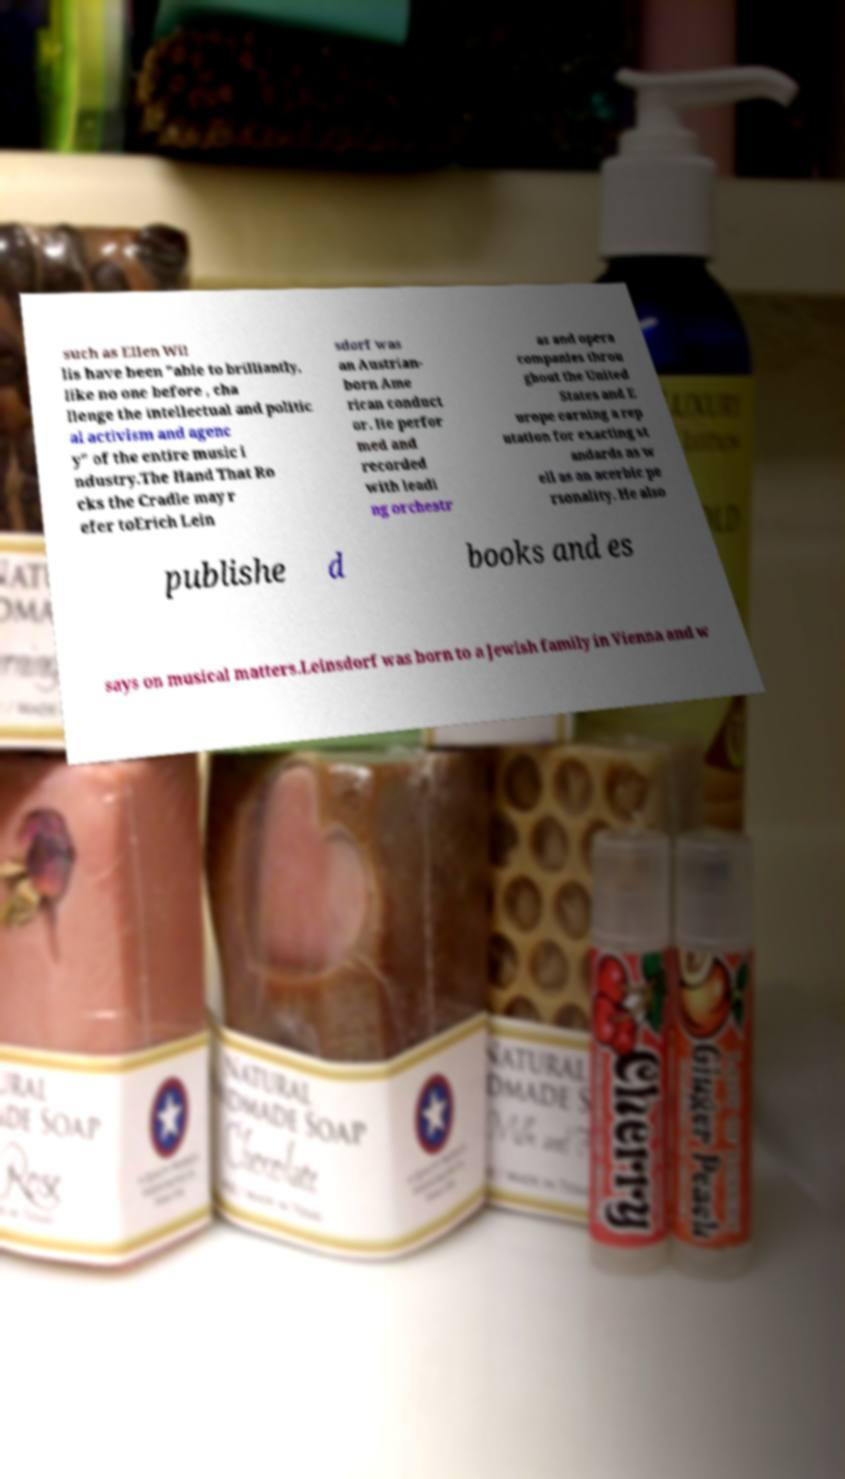Could you assist in decoding the text presented in this image and type it out clearly? such as Ellen Wil lis have been "able to brilliantly, like no one before , cha llenge the intellectual and politic al activism and agenc y" of the entire music i ndustry.The Hand That Ro cks the Cradle may r efer toErich Lein sdorf was an Austrian- born Ame rican conduct or. He perfor med and recorded with leadi ng orchestr as and opera companies throu ghout the United States and E urope earning a rep utation for exacting st andards as w ell as an acerbic pe rsonality. He also publishe d books and es says on musical matters.Leinsdorf was born to a Jewish family in Vienna and w 